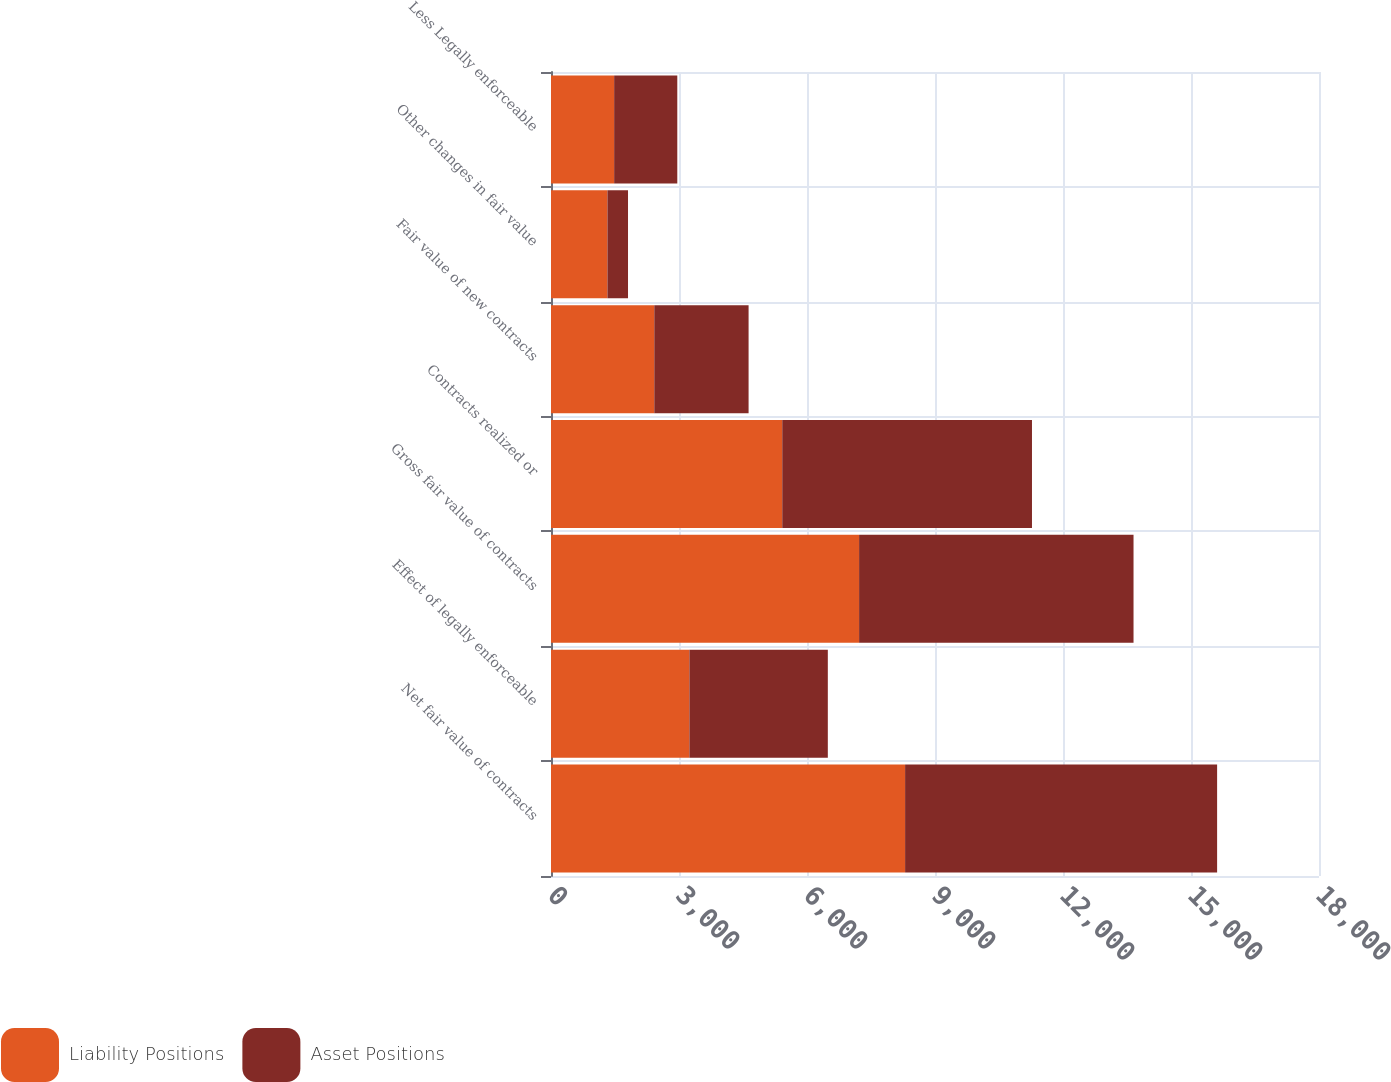Convert chart. <chart><loc_0><loc_0><loc_500><loc_500><stacked_bar_chart><ecel><fcel>Net fair value of contracts<fcel>Effect of legally enforceable<fcel>Gross fair value of contracts<fcel>Contracts realized or<fcel>Fair value of new contracts<fcel>Other changes in fair value<fcel>Less Legally enforceable<nl><fcel>Liability Positions<fcel>8299<fcel>3244<fcel>7221<fcel>5420<fcel>2421<fcel>1323<fcel>1480<nl><fcel>Asset Positions<fcel>7313<fcel>3244<fcel>6432<fcel>5853<fcel>2210<fcel>482<fcel>1480<nl></chart> 